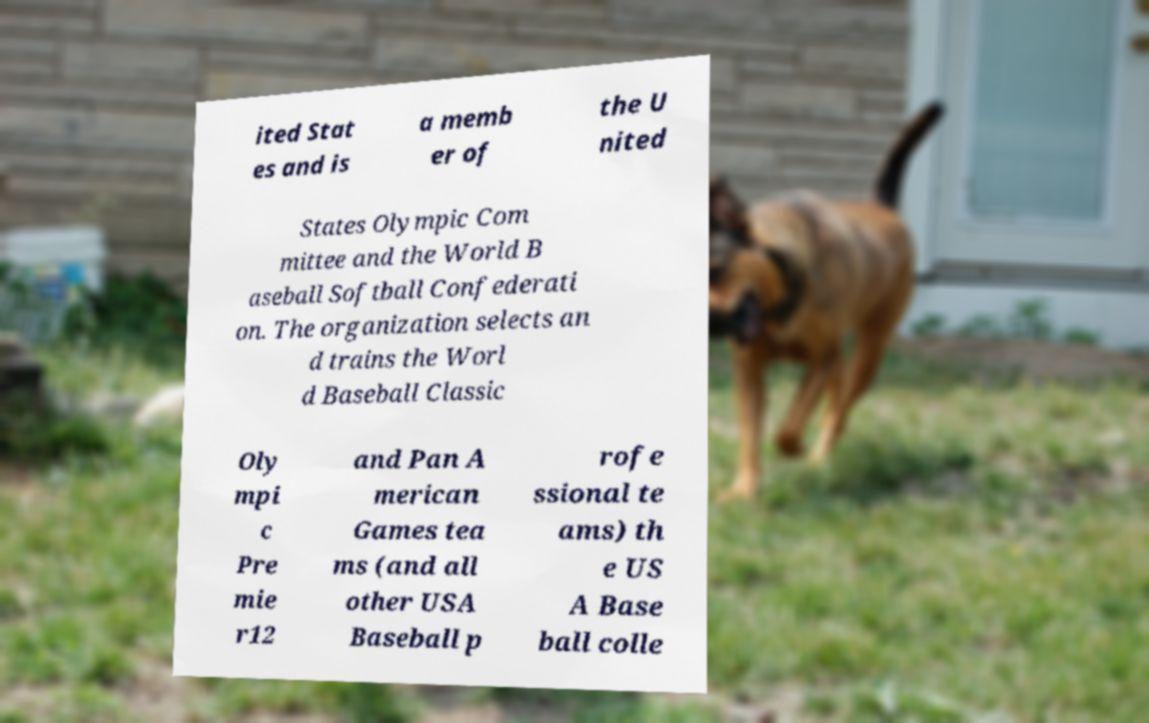Could you assist in decoding the text presented in this image and type it out clearly? ited Stat es and is a memb er of the U nited States Olympic Com mittee and the World B aseball Softball Confederati on. The organization selects an d trains the Worl d Baseball Classic Oly mpi c Pre mie r12 and Pan A merican Games tea ms (and all other USA Baseball p rofe ssional te ams) th e US A Base ball colle 